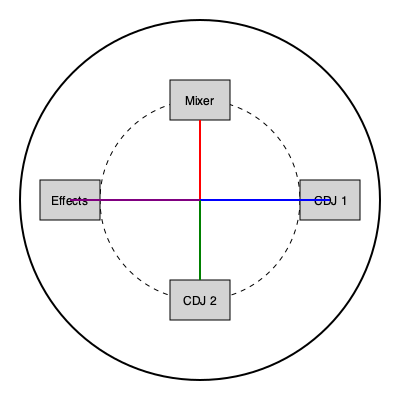As a DJ specializing in country-dance fusion, you're setting up your equipment on a circular turntable. The mixer is placed at the 12 o'clock position, CDJ 1 at 3 o'clock, CDJ 2 at 6 o'clock, and the effects unit at 9 o'clock. If the radius of the turntable is 180 cm and all equipment is placed halfway between the center and the edge, what is the shortest distance between any two pieces of equipment? Let's approach this step-by-step:

1) The equipment is placed in a circle with a radius of 90 cm (half of 180 cm).

2) The equipment forms a square inside this circle, with the center of the turntable at the center of the square.

3) To find the side length of this square, we can use the formula for the diagonal of a square inscribed in a circle:
   $d = r\sqrt{2}$, where $d$ is the diagonal and $r$ is the radius.

4) In this case, $r = 90$ cm, so:
   $d = 90\sqrt{2}$ cm

5) The diagonal of the square is the diameter of the circle, so the side length of the square is this diagonal divided by $\sqrt{2}$:
   $s = \frac{90\sqrt{2}}{\sqrt{2}} = 90$ cm

6) Therefore, the shortest distance between any two adjacent pieces of equipment is 90 cm.

This setup allows for easy transitions between tracks, perfect for mixing Jon Pardi's country hits with dance beats.
Answer: 90 cm 